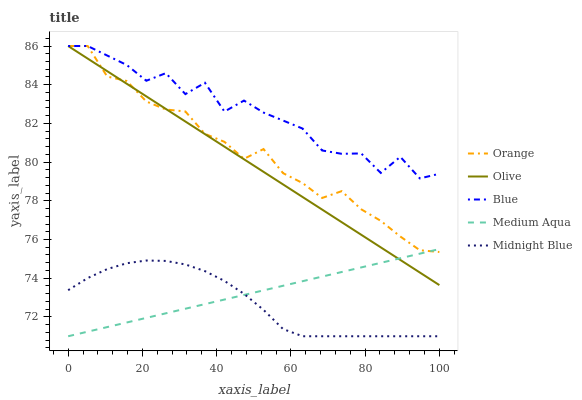Does Midnight Blue have the minimum area under the curve?
Answer yes or no. Yes. Does Blue have the maximum area under the curve?
Answer yes or no. Yes. Does Olive have the minimum area under the curve?
Answer yes or no. No. Does Olive have the maximum area under the curve?
Answer yes or no. No. Is Olive the smoothest?
Answer yes or no. Yes. Is Blue the roughest?
Answer yes or no. Yes. Is Medium Aqua the smoothest?
Answer yes or no. No. Is Medium Aqua the roughest?
Answer yes or no. No. Does Medium Aqua have the lowest value?
Answer yes or no. Yes. Does Olive have the lowest value?
Answer yes or no. No. Does Blue have the highest value?
Answer yes or no. Yes. Does Medium Aqua have the highest value?
Answer yes or no. No. Is Medium Aqua less than Blue?
Answer yes or no. Yes. Is Blue greater than Midnight Blue?
Answer yes or no. Yes. Does Medium Aqua intersect Midnight Blue?
Answer yes or no. Yes. Is Medium Aqua less than Midnight Blue?
Answer yes or no. No. Is Medium Aqua greater than Midnight Blue?
Answer yes or no. No. Does Medium Aqua intersect Blue?
Answer yes or no. No. 